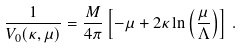Convert formula to latex. <formula><loc_0><loc_0><loc_500><loc_500>\frac { 1 } { V _ { 0 } ( \kappa , \mu ) } = \frac { M } { 4 \pi } \left [ - \mu + 2 \kappa \ln \left ( \frac { \mu } { \Lambda } \right ) \right ] \, .</formula> 